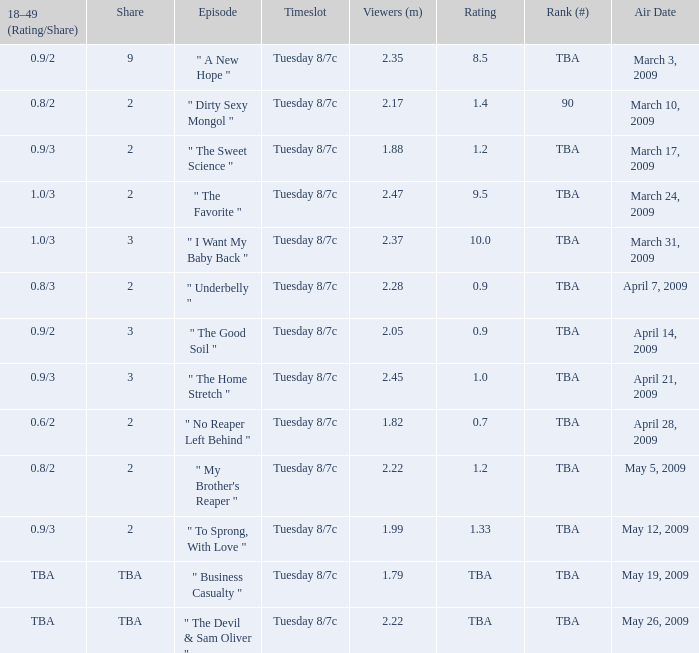What is the score of the program with a tba ranking, which was broadcasted on april 21st, 2009? 1.0. 